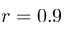<formula> <loc_0><loc_0><loc_500><loc_500>r = 0 . 9</formula> 